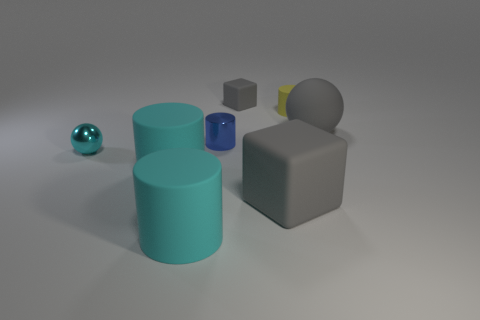Subtract all blue cylinders. How many cylinders are left? 3 Subtract all blue cylinders. How many cylinders are left? 3 Subtract all green cylinders. Subtract all green spheres. How many cylinders are left? 4 Add 1 metallic cylinders. How many objects exist? 9 Subtract all cubes. How many objects are left? 6 Add 6 large blue objects. How many large blue objects exist? 6 Subtract 0 red spheres. How many objects are left? 8 Subtract all green cubes. Subtract all tiny matte cubes. How many objects are left? 7 Add 2 big cylinders. How many big cylinders are left? 4 